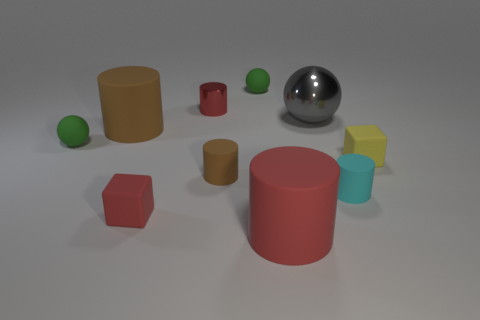Subtract all brown cylinders. How many cylinders are left? 3 Subtract all shiny cylinders. How many cylinders are left? 4 Subtract all green balls. How many were subtracted if there are1green balls left? 1 Subtract all red spheres. Subtract all brown cylinders. How many spheres are left? 3 Subtract all gray blocks. How many green balls are left? 2 Subtract all gray objects. Subtract all tiny matte cubes. How many objects are left? 7 Add 5 red objects. How many red objects are left? 8 Add 8 brown metallic cylinders. How many brown metallic cylinders exist? 8 Subtract 1 cyan cylinders. How many objects are left? 9 Subtract all cubes. How many objects are left? 8 